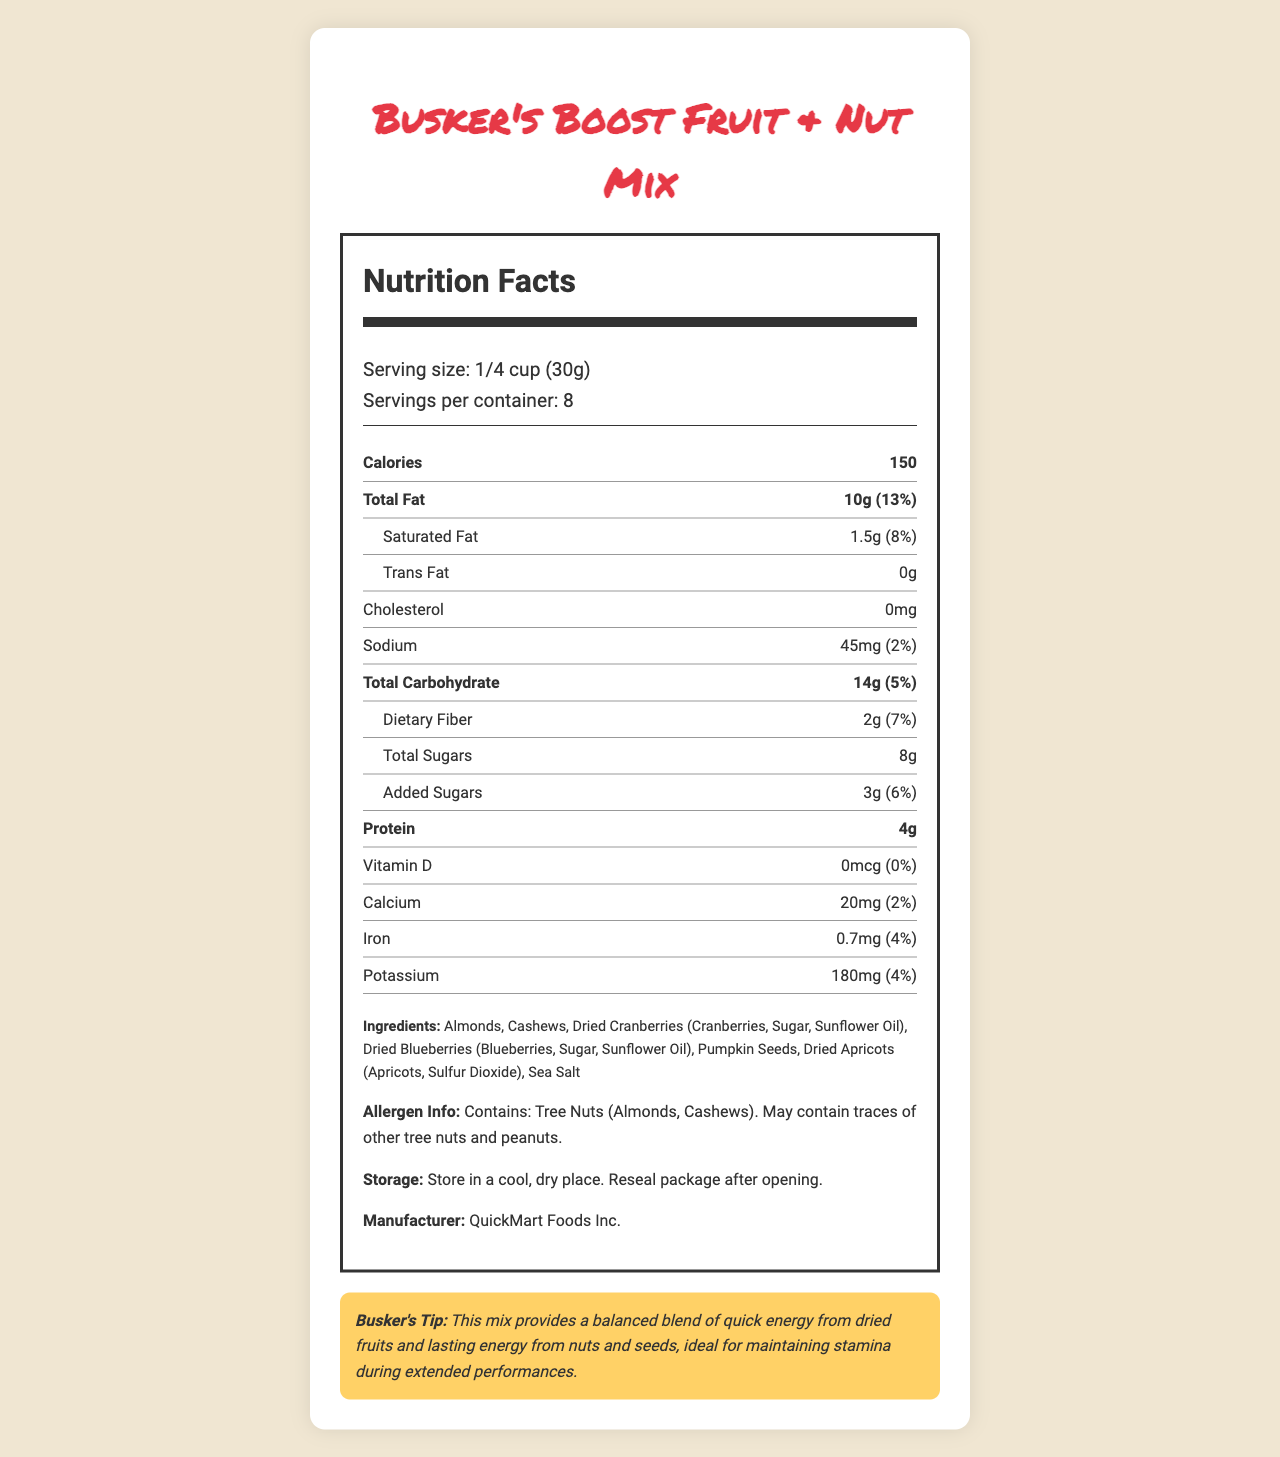What is the serving size for Busker's Boost Fruit & Nut Mix? The serving size is explicitly stated as 1/4 cup (30g) in the nutritional label.
Answer: 1/4 cup (30g) How many calories are in one serving of Busker's Boost Fruit & Nut Mix? The calorie content per serving is listed as 150.
Answer: 150 What is the daily value percentage of Total Fat? The nutritional facts indicate that Total Fat comprises 13% of the daily value.
Answer: 13% Does Busker's Boost Fruit & Nut Mix contain any trans fat? The document lists the amount of Trans Fat as 0g, indicating there is no trans fat.
Answer: No What is the protein content per serving? The label specifies that there are 4 grams of protein per serving.
Answer: 4g How many servings are in each container? A. 4 B. 6 C. 8 D. 10 The label clearly states that there are 8 servings per container.
Answer: C. 8 Which ingredient is not in Busker's Boost Fruit & Nut Mix? A. Almonds B. Dried Pineapple C. Cashews D. Pumpkin Seeds The ingredients list does not contain Dried Pineapple but includes Almonds, Cashews, and Pumpkin Seeds.
Answer: B. Dried Pineapple Does this mix contain any added sugars? The label shows that it contains 3g of added sugars, which is 6% of the daily value.
Answer: Yes Summarize the main idea of the document. The document includes nutrition details such as calorie count, fat content, protein content, and vitamin levels, ingredients used, allergen information, and storage instructions. The busker's tip highlights the product as a balanced energy source for performers.
Answer: The document provides detailed nutrition facts, ingredient information, and a busker's tip for a pre-packaged fruit and nut mix called Busker's Boost Fruit & Nut Mix, produced by QuickMart Foods Inc. What is the total carbohydrate content of this product per serving? The total carbohydrate content per serving is listed as 14 grams.
Answer: 14g Can the exact manufacturing process be determined from this document? The document does not provide any details regarding the manufacturing process, such as specific techniques or machinery used.
Answer: No What are the allergens present in this mix? The allergen information clearly notes that the product contains Tree Nuts (Almonds, Cashews) and may contain traces of other tree nuts and peanuts.
Answer: Tree Nuts (Almonds, Cashews). May contain traces of other tree nuts and peanuts. Which nutrient contributes 7% to the daily value per serving? A. Fiber B. Protein C. Sodium D. Calcium The daily value for Dietary Fiber per serving is 7%, which matches the given options.
Answer: A. Fiber What type of fat contributes 1.5g in the nutritional information? The nutritional facts list 1.5g of Saturated Fat per serving.
Answer: Saturated Fat 